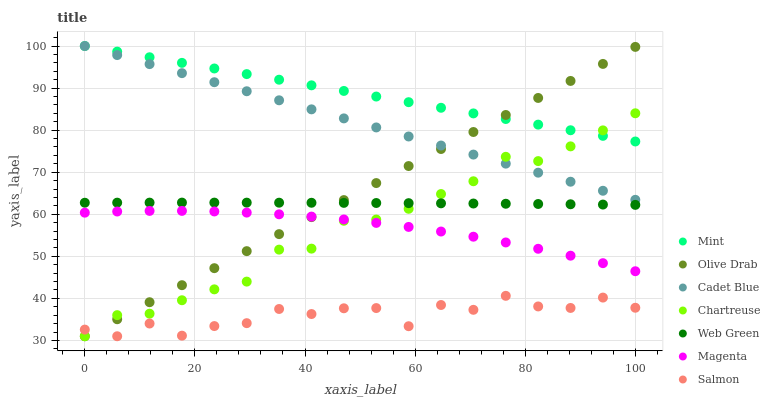Does Salmon have the minimum area under the curve?
Answer yes or no. Yes. Does Mint have the maximum area under the curve?
Answer yes or no. Yes. Does Web Green have the minimum area under the curve?
Answer yes or no. No. Does Web Green have the maximum area under the curve?
Answer yes or no. No. Is Cadet Blue the smoothest?
Answer yes or no. Yes. Is Salmon the roughest?
Answer yes or no. Yes. Is Web Green the smoothest?
Answer yes or no. No. Is Web Green the roughest?
Answer yes or no. No. Does Salmon have the lowest value?
Answer yes or no. Yes. Does Web Green have the lowest value?
Answer yes or no. No. Does Mint have the highest value?
Answer yes or no. Yes. Does Web Green have the highest value?
Answer yes or no. No. Is Magenta less than Web Green?
Answer yes or no. Yes. Is Cadet Blue greater than Magenta?
Answer yes or no. Yes. Does Chartreuse intersect Mint?
Answer yes or no. Yes. Is Chartreuse less than Mint?
Answer yes or no. No. Is Chartreuse greater than Mint?
Answer yes or no. No. Does Magenta intersect Web Green?
Answer yes or no. No. 